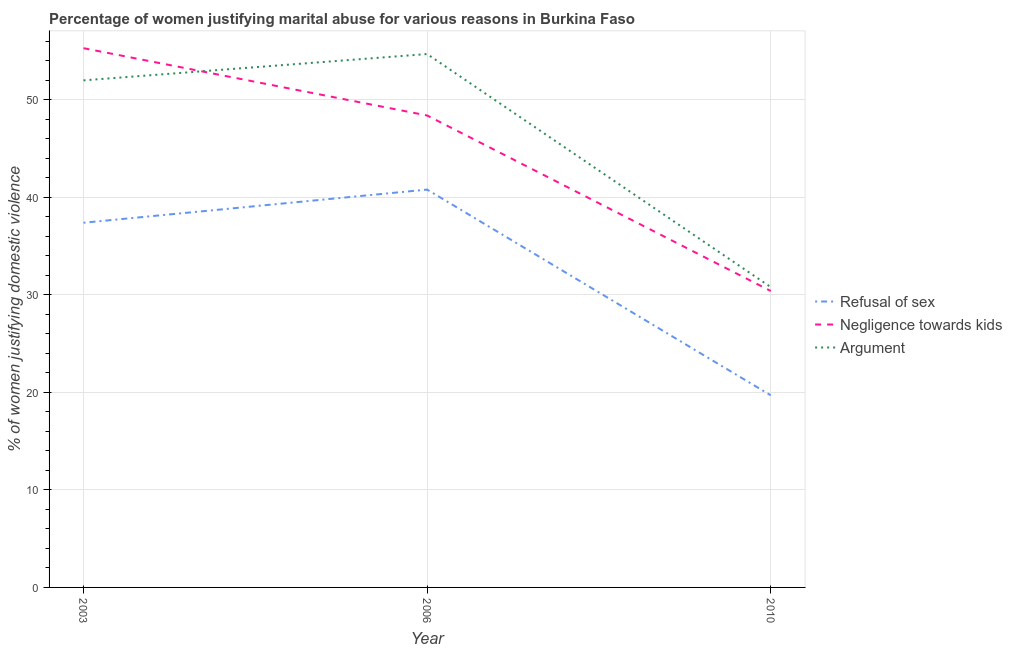How many different coloured lines are there?
Your response must be concise. 3. Is the number of lines equal to the number of legend labels?
Provide a short and direct response. Yes. Across all years, what is the maximum percentage of women justifying domestic violence due to refusal of sex?
Your response must be concise. 40.8. Across all years, what is the minimum percentage of women justifying domestic violence due to arguments?
Make the answer very short. 30.8. In which year was the percentage of women justifying domestic violence due to arguments maximum?
Offer a very short reply. 2006. What is the total percentage of women justifying domestic violence due to arguments in the graph?
Your answer should be very brief. 137.5. What is the difference between the percentage of women justifying domestic violence due to negligence towards kids in 2006 and that in 2010?
Offer a very short reply. 18. What is the difference between the percentage of women justifying domestic violence due to refusal of sex in 2006 and the percentage of women justifying domestic violence due to arguments in 2003?
Keep it short and to the point. -11.2. What is the average percentage of women justifying domestic violence due to negligence towards kids per year?
Ensure brevity in your answer.  44.7. In the year 2003, what is the difference between the percentage of women justifying domestic violence due to refusal of sex and percentage of women justifying domestic violence due to arguments?
Offer a terse response. -14.6. What is the ratio of the percentage of women justifying domestic violence due to arguments in 2003 to that in 2010?
Provide a succinct answer. 1.69. Is the difference between the percentage of women justifying domestic violence due to negligence towards kids in 2006 and 2010 greater than the difference between the percentage of women justifying domestic violence due to arguments in 2006 and 2010?
Offer a terse response. No. What is the difference between the highest and the second highest percentage of women justifying domestic violence due to arguments?
Keep it short and to the point. 2.7. What is the difference between the highest and the lowest percentage of women justifying domestic violence due to negligence towards kids?
Your answer should be compact. 24.9. In how many years, is the percentage of women justifying domestic violence due to negligence towards kids greater than the average percentage of women justifying domestic violence due to negligence towards kids taken over all years?
Ensure brevity in your answer.  2. Is the percentage of women justifying domestic violence due to refusal of sex strictly less than the percentage of women justifying domestic violence due to negligence towards kids over the years?
Offer a terse response. Yes. How many lines are there?
Your response must be concise. 3. Are the values on the major ticks of Y-axis written in scientific E-notation?
Offer a terse response. No. Does the graph contain grids?
Offer a very short reply. Yes. What is the title of the graph?
Ensure brevity in your answer.  Percentage of women justifying marital abuse for various reasons in Burkina Faso. What is the label or title of the X-axis?
Make the answer very short. Year. What is the label or title of the Y-axis?
Give a very brief answer. % of women justifying domestic violence. What is the % of women justifying domestic violence in Refusal of sex in 2003?
Your answer should be very brief. 37.4. What is the % of women justifying domestic violence of Negligence towards kids in 2003?
Your answer should be compact. 55.3. What is the % of women justifying domestic violence in Refusal of sex in 2006?
Your response must be concise. 40.8. What is the % of women justifying domestic violence in Negligence towards kids in 2006?
Your answer should be very brief. 48.4. What is the % of women justifying domestic violence in Argument in 2006?
Keep it short and to the point. 54.7. What is the % of women justifying domestic violence in Refusal of sex in 2010?
Keep it short and to the point. 19.7. What is the % of women justifying domestic violence in Negligence towards kids in 2010?
Your answer should be very brief. 30.4. What is the % of women justifying domestic violence in Argument in 2010?
Keep it short and to the point. 30.8. Across all years, what is the maximum % of women justifying domestic violence in Refusal of sex?
Your answer should be compact. 40.8. Across all years, what is the maximum % of women justifying domestic violence in Negligence towards kids?
Make the answer very short. 55.3. Across all years, what is the maximum % of women justifying domestic violence in Argument?
Offer a terse response. 54.7. Across all years, what is the minimum % of women justifying domestic violence in Refusal of sex?
Provide a succinct answer. 19.7. Across all years, what is the minimum % of women justifying domestic violence in Negligence towards kids?
Offer a terse response. 30.4. Across all years, what is the minimum % of women justifying domestic violence in Argument?
Your answer should be compact. 30.8. What is the total % of women justifying domestic violence in Refusal of sex in the graph?
Offer a very short reply. 97.9. What is the total % of women justifying domestic violence in Negligence towards kids in the graph?
Keep it short and to the point. 134.1. What is the total % of women justifying domestic violence of Argument in the graph?
Offer a very short reply. 137.5. What is the difference between the % of women justifying domestic violence of Refusal of sex in 2003 and that in 2010?
Your response must be concise. 17.7. What is the difference between the % of women justifying domestic violence of Negligence towards kids in 2003 and that in 2010?
Provide a short and direct response. 24.9. What is the difference between the % of women justifying domestic violence in Argument in 2003 and that in 2010?
Give a very brief answer. 21.2. What is the difference between the % of women justifying domestic violence in Refusal of sex in 2006 and that in 2010?
Provide a short and direct response. 21.1. What is the difference between the % of women justifying domestic violence of Argument in 2006 and that in 2010?
Keep it short and to the point. 23.9. What is the difference between the % of women justifying domestic violence in Refusal of sex in 2003 and the % of women justifying domestic violence in Argument in 2006?
Your response must be concise. -17.3. What is the difference between the % of women justifying domestic violence of Negligence towards kids in 2003 and the % of women justifying domestic violence of Argument in 2006?
Your answer should be compact. 0.6. What is the difference between the % of women justifying domestic violence in Negligence towards kids in 2003 and the % of women justifying domestic violence in Argument in 2010?
Offer a terse response. 24.5. What is the difference between the % of women justifying domestic violence in Refusal of sex in 2006 and the % of women justifying domestic violence in Negligence towards kids in 2010?
Offer a terse response. 10.4. What is the difference between the % of women justifying domestic violence in Refusal of sex in 2006 and the % of women justifying domestic violence in Argument in 2010?
Your answer should be compact. 10. What is the average % of women justifying domestic violence in Refusal of sex per year?
Offer a terse response. 32.63. What is the average % of women justifying domestic violence in Negligence towards kids per year?
Make the answer very short. 44.7. What is the average % of women justifying domestic violence in Argument per year?
Provide a short and direct response. 45.83. In the year 2003, what is the difference between the % of women justifying domestic violence of Refusal of sex and % of women justifying domestic violence of Negligence towards kids?
Offer a terse response. -17.9. In the year 2003, what is the difference between the % of women justifying domestic violence of Refusal of sex and % of women justifying domestic violence of Argument?
Offer a terse response. -14.6. In the year 2006, what is the difference between the % of women justifying domestic violence of Refusal of sex and % of women justifying domestic violence of Negligence towards kids?
Your answer should be very brief. -7.6. In the year 2010, what is the difference between the % of women justifying domestic violence of Refusal of sex and % of women justifying domestic violence of Negligence towards kids?
Your answer should be compact. -10.7. In the year 2010, what is the difference between the % of women justifying domestic violence in Refusal of sex and % of women justifying domestic violence in Argument?
Offer a very short reply. -11.1. In the year 2010, what is the difference between the % of women justifying domestic violence of Negligence towards kids and % of women justifying domestic violence of Argument?
Make the answer very short. -0.4. What is the ratio of the % of women justifying domestic violence in Negligence towards kids in 2003 to that in 2006?
Your answer should be very brief. 1.14. What is the ratio of the % of women justifying domestic violence of Argument in 2003 to that in 2006?
Provide a succinct answer. 0.95. What is the ratio of the % of women justifying domestic violence of Refusal of sex in 2003 to that in 2010?
Ensure brevity in your answer.  1.9. What is the ratio of the % of women justifying domestic violence in Negligence towards kids in 2003 to that in 2010?
Your answer should be compact. 1.82. What is the ratio of the % of women justifying domestic violence of Argument in 2003 to that in 2010?
Your answer should be compact. 1.69. What is the ratio of the % of women justifying domestic violence of Refusal of sex in 2006 to that in 2010?
Provide a succinct answer. 2.07. What is the ratio of the % of women justifying domestic violence of Negligence towards kids in 2006 to that in 2010?
Provide a short and direct response. 1.59. What is the ratio of the % of women justifying domestic violence in Argument in 2006 to that in 2010?
Provide a short and direct response. 1.78. What is the difference between the highest and the second highest % of women justifying domestic violence in Refusal of sex?
Your answer should be compact. 3.4. What is the difference between the highest and the second highest % of women justifying domestic violence in Negligence towards kids?
Provide a short and direct response. 6.9. What is the difference between the highest and the lowest % of women justifying domestic violence of Refusal of sex?
Provide a short and direct response. 21.1. What is the difference between the highest and the lowest % of women justifying domestic violence of Negligence towards kids?
Your response must be concise. 24.9. What is the difference between the highest and the lowest % of women justifying domestic violence in Argument?
Make the answer very short. 23.9. 